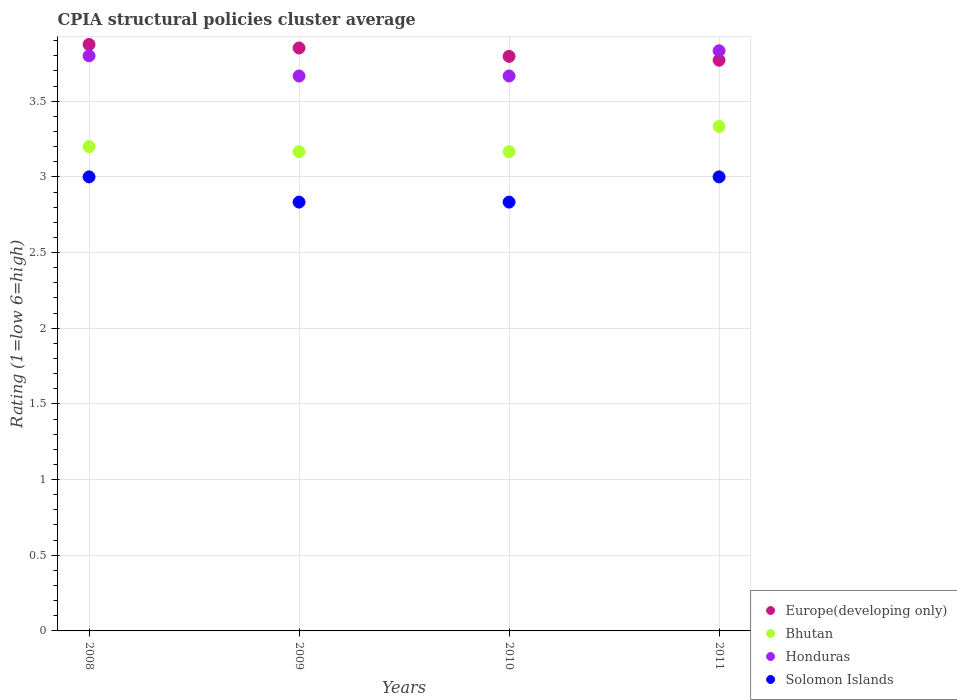How many different coloured dotlines are there?
Provide a succinct answer. 4. What is the CPIA rating in Europe(developing only) in 2010?
Offer a terse response. 3.8. Across all years, what is the maximum CPIA rating in Bhutan?
Provide a succinct answer. 3.33. Across all years, what is the minimum CPIA rating in Europe(developing only)?
Your response must be concise. 3.77. In which year was the CPIA rating in Europe(developing only) minimum?
Provide a short and direct response. 2011. What is the total CPIA rating in Bhutan in the graph?
Provide a short and direct response. 12.87. What is the difference between the CPIA rating in Bhutan in 2008 and that in 2010?
Provide a succinct answer. 0.03. What is the difference between the CPIA rating in Solomon Islands in 2008 and the CPIA rating in Europe(developing only) in 2009?
Make the answer very short. -0.85. What is the average CPIA rating in Solomon Islands per year?
Your answer should be very brief. 2.92. In the year 2011, what is the difference between the CPIA rating in Bhutan and CPIA rating in Honduras?
Offer a very short reply. -0.5. In how many years, is the CPIA rating in Bhutan greater than 3.5?
Your answer should be compact. 0. What is the ratio of the CPIA rating in Solomon Islands in 2008 to that in 2009?
Provide a short and direct response. 1.06. Is the CPIA rating in Europe(developing only) in 2008 less than that in 2009?
Give a very brief answer. No. Is the difference between the CPIA rating in Bhutan in 2008 and 2010 greater than the difference between the CPIA rating in Honduras in 2008 and 2010?
Offer a terse response. No. What is the difference between the highest and the lowest CPIA rating in Solomon Islands?
Offer a very short reply. 0.17. In how many years, is the CPIA rating in Europe(developing only) greater than the average CPIA rating in Europe(developing only) taken over all years?
Offer a terse response. 2. Is the CPIA rating in Europe(developing only) strictly greater than the CPIA rating in Honduras over the years?
Provide a short and direct response. No. Is the CPIA rating in Europe(developing only) strictly less than the CPIA rating in Honduras over the years?
Your answer should be very brief. No. How many dotlines are there?
Give a very brief answer. 4. What is the difference between two consecutive major ticks on the Y-axis?
Your answer should be compact. 0.5. Does the graph contain any zero values?
Your answer should be compact. No. Does the graph contain grids?
Keep it short and to the point. Yes. What is the title of the graph?
Give a very brief answer. CPIA structural policies cluster average. What is the label or title of the X-axis?
Provide a succinct answer. Years. What is the Rating (1=low 6=high) of Europe(developing only) in 2008?
Your response must be concise. 3.88. What is the Rating (1=low 6=high) of Europe(developing only) in 2009?
Your response must be concise. 3.85. What is the Rating (1=low 6=high) of Bhutan in 2009?
Offer a terse response. 3.17. What is the Rating (1=low 6=high) in Honduras in 2009?
Make the answer very short. 3.67. What is the Rating (1=low 6=high) in Solomon Islands in 2009?
Your answer should be very brief. 2.83. What is the Rating (1=low 6=high) of Europe(developing only) in 2010?
Ensure brevity in your answer.  3.8. What is the Rating (1=low 6=high) in Bhutan in 2010?
Give a very brief answer. 3.17. What is the Rating (1=low 6=high) in Honduras in 2010?
Keep it short and to the point. 3.67. What is the Rating (1=low 6=high) in Solomon Islands in 2010?
Your response must be concise. 2.83. What is the Rating (1=low 6=high) of Europe(developing only) in 2011?
Provide a short and direct response. 3.77. What is the Rating (1=low 6=high) in Bhutan in 2011?
Ensure brevity in your answer.  3.33. What is the Rating (1=low 6=high) in Honduras in 2011?
Your answer should be compact. 3.83. Across all years, what is the maximum Rating (1=low 6=high) in Europe(developing only)?
Ensure brevity in your answer.  3.88. Across all years, what is the maximum Rating (1=low 6=high) in Bhutan?
Keep it short and to the point. 3.33. Across all years, what is the maximum Rating (1=low 6=high) in Honduras?
Ensure brevity in your answer.  3.83. Across all years, what is the minimum Rating (1=low 6=high) in Europe(developing only)?
Your answer should be very brief. 3.77. Across all years, what is the minimum Rating (1=low 6=high) of Bhutan?
Give a very brief answer. 3.17. Across all years, what is the minimum Rating (1=low 6=high) in Honduras?
Ensure brevity in your answer.  3.67. Across all years, what is the minimum Rating (1=low 6=high) of Solomon Islands?
Your answer should be compact. 2.83. What is the total Rating (1=low 6=high) of Europe(developing only) in the graph?
Ensure brevity in your answer.  15.29. What is the total Rating (1=low 6=high) in Bhutan in the graph?
Keep it short and to the point. 12.87. What is the total Rating (1=low 6=high) in Honduras in the graph?
Make the answer very short. 14.97. What is the total Rating (1=low 6=high) of Solomon Islands in the graph?
Offer a very short reply. 11.67. What is the difference between the Rating (1=low 6=high) in Europe(developing only) in 2008 and that in 2009?
Offer a terse response. 0.02. What is the difference between the Rating (1=low 6=high) of Bhutan in 2008 and that in 2009?
Make the answer very short. 0.03. What is the difference between the Rating (1=low 6=high) in Honduras in 2008 and that in 2009?
Your answer should be very brief. 0.13. What is the difference between the Rating (1=low 6=high) of Europe(developing only) in 2008 and that in 2010?
Your answer should be compact. 0.08. What is the difference between the Rating (1=low 6=high) of Bhutan in 2008 and that in 2010?
Ensure brevity in your answer.  0.03. What is the difference between the Rating (1=low 6=high) in Honduras in 2008 and that in 2010?
Ensure brevity in your answer.  0.13. What is the difference between the Rating (1=low 6=high) of Solomon Islands in 2008 and that in 2010?
Keep it short and to the point. 0.17. What is the difference between the Rating (1=low 6=high) in Europe(developing only) in 2008 and that in 2011?
Your response must be concise. 0.1. What is the difference between the Rating (1=low 6=high) in Bhutan in 2008 and that in 2011?
Provide a succinct answer. -0.13. What is the difference between the Rating (1=low 6=high) in Honduras in 2008 and that in 2011?
Your response must be concise. -0.03. What is the difference between the Rating (1=low 6=high) in Europe(developing only) in 2009 and that in 2010?
Offer a very short reply. 0.06. What is the difference between the Rating (1=low 6=high) in Bhutan in 2009 and that in 2010?
Your answer should be compact. 0. What is the difference between the Rating (1=low 6=high) of Honduras in 2009 and that in 2010?
Make the answer very short. 0. What is the difference between the Rating (1=low 6=high) of Europe(developing only) in 2009 and that in 2011?
Provide a succinct answer. 0.08. What is the difference between the Rating (1=low 6=high) of Honduras in 2009 and that in 2011?
Your answer should be compact. -0.17. What is the difference between the Rating (1=low 6=high) of Solomon Islands in 2009 and that in 2011?
Your answer should be compact. -0.17. What is the difference between the Rating (1=low 6=high) in Europe(developing only) in 2010 and that in 2011?
Offer a very short reply. 0.03. What is the difference between the Rating (1=low 6=high) of Honduras in 2010 and that in 2011?
Your answer should be compact. -0.17. What is the difference between the Rating (1=low 6=high) of Solomon Islands in 2010 and that in 2011?
Provide a succinct answer. -0.17. What is the difference between the Rating (1=low 6=high) of Europe(developing only) in 2008 and the Rating (1=low 6=high) of Bhutan in 2009?
Give a very brief answer. 0.71. What is the difference between the Rating (1=low 6=high) of Europe(developing only) in 2008 and the Rating (1=low 6=high) of Honduras in 2009?
Provide a succinct answer. 0.21. What is the difference between the Rating (1=low 6=high) in Europe(developing only) in 2008 and the Rating (1=low 6=high) in Solomon Islands in 2009?
Keep it short and to the point. 1.04. What is the difference between the Rating (1=low 6=high) of Bhutan in 2008 and the Rating (1=low 6=high) of Honduras in 2009?
Ensure brevity in your answer.  -0.47. What is the difference between the Rating (1=low 6=high) of Bhutan in 2008 and the Rating (1=low 6=high) of Solomon Islands in 2009?
Your response must be concise. 0.37. What is the difference between the Rating (1=low 6=high) in Honduras in 2008 and the Rating (1=low 6=high) in Solomon Islands in 2009?
Offer a terse response. 0.97. What is the difference between the Rating (1=low 6=high) in Europe(developing only) in 2008 and the Rating (1=low 6=high) in Bhutan in 2010?
Make the answer very short. 0.71. What is the difference between the Rating (1=low 6=high) in Europe(developing only) in 2008 and the Rating (1=low 6=high) in Honduras in 2010?
Provide a succinct answer. 0.21. What is the difference between the Rating (1=low 6=high) of Europe(developing only) in 2008 and the Rating (1=low 6=high) of Solomon Islands in 2010?
Make the answer very short. 1.04. What is the difference between the Rating (1=low 6=high) of Bhutan in 2008 and the Rating (1=low 6=high) of Honduras in 2010?
Provide a short and direct response. -0.47. What is the difference between the Rating (1=low 6=high) in Bhutan in 2008 and the Rating (1=low 6=high) in Solomon Islands in 2010?
Your answer should be compact. 0.37. What is the difference between the Rating (1=low 6=high) of Honduras in 2008 and the Rating (1=low 6=high) of Solomon Islands in 2010?
Offer a terse response. 0.97. What is the difference between the Rating (1=low 6=high) of Europe(developing only) in 2008 and the Rating (1=low 6=high) of Bhutan in 2011?
Your response must be concise. 0.54. What is the difference between the Rating (1=low 6=high) in Europe(developing only) in 2008 and the Rating (1=low 6=high) in Honduras in 2011?
Make the answer very short. 0.04. What is the difference between the Rating (1=low 6=high) of Bhutan in 2008 and the Rating (1=low 6=high) of Honduras in 2011?
Offer a terse response. -0.63. What is the difference between the Rating (1=low 6=high) in Bhutan in 2008 and the Rating (1=low 6=high) in Solomon Islands in 2011?
Ensure brevity in your answer.  0.2. What is the difference between the Rating (1=low 6=high) of Honduras in 2008 and the Rating (1=low 6=high) of Solomon Islands in 2011?
Offer a very short reply. 0.8. What is the difference between the Rating (1=low 6=high) in Europe(developing only) in 2009 and the Rating (1=low 6=high) in Bhutan in 2010?
Your response must be concise. 0.69. What is the difference between the Rating (1=low 6=high) of Europe(developing only) in 2009 and the Rating (1=low 6=high) of Honduras in 2010?
Offer a very short reply. 0.19. What is the difference between the Rating (1=low 6=high) in Europe(developing only) in 2009 and the Rating (1=low 6=high) in Solomon Islands in 2010?
Ensure brevity in your answer.  1.02. What is the difference between the Rating (1=low 6=high) in Bhutan in 2009 and the Rating (1=low 6=high) in Honduras in 2010?
Your response must be concise. -0.5. What is the difference between the Rating (1=low 6=high) of Bhutan in 2009 and the Rating (1=low 6=high) of Solomon Islands in 2010?
Your answer should be very brief. 0.33. What is the difference between the Rating (1=low 6=high) of Honduras in 2009 and the Rating (1=low 6=high) of Solomon Islands in 2010?
Offer a terse response. 0.83. What is the difference between the Rating (1=low 6=high) of Europe(developing only) in 2009 and the Rating (1=low 6=high) of Bhutan in 2011?
Your response must be concise. 0.52. What is the difference between the Rating (1=low 6=high) of Europe(developing only) in 2009 and the Rating (1=low 6=high) of Honduras in 2011?
Make the answer very short. 0.02. What is the difference between the Rating (1=low 6=high) in Europe(developing only) in 2009 and the Rating (1=low 6=high) in Solomon Islands in 2011?
Your answer should be very brief. 0.85. What is the difference between the Rating (1=low 6=high) in Bhutan in 2009 and the Rating (1=low 6=high) in Honduras in 2011?
Offer a terse response. -0.67. What is the difference between the Rating (1=low 6=high) of Bhutan in 2009 and the Rating (1=low 6=high) of Solomon Islands in 2011?
Your answer should be very brief. 0.17. What is the difference between the Rating (1=low 6=high) of Honduras in 2009 and the Rating (1=low 6=high) of Solomon Islands in 2011?
Ensure brevity in your answer.  0.67. What is the difference between the Rating (1=low 6=high) of Europe(developing only) in 2010 and the Rating (1=low 6=high) of Bhutan in 2011?
Your answer should be very brief. 0.46. What is the difference between the Rating (1=low 6=high) in Europe(developing only) in 2010 and the Rating (1=low 6=high) in Honduras in 2011?
Make the answer very short. -0.04. What is the difference between the Rating (1=low 6=high) of Europe(developing only) in 2010 and the Rating (1=low 6=high) of Solomon Islands in 2011?
Ensure brevity in your answer.  0.8. What is the difference between the Rating (1=low 6=high) in Bhutan in 2010 and the Rating (1=low 6=high) in Solomon Islands in 2011?
Keep it short and to the point. 0.17. What is the difference between the Rating (1=low 6=high) in Honduras in 2010 and the Rating (1=low 6=high) in Solomon Islands in 2011?
Ensure brevity in your answer.  0.67. What is the average Rating (1=low 6=high) of Europe(developing only) per year?
Your answer should be very brief. 3.82. What is the average Rating (1=low 6=high) of Bhutan per year?
Give a very brief answer. 3.22. What is the average Rating (1=low 6=high) in Honduras per year?
Give a very brief answer. 3.74. What is the average Rating (1=low 6=high) of Solomon Islands per year?
Your answer should be very brief. 2.92. In the year 2008, what is the difference between the Rating (1=low 6=high) in Europe(developing only) and Rating (1=low 6=high) in Bhutan?
Give a very brief answer. 0.68. In the year 2008, what is the difference between the Rating (1=low 6=high) in Europe(developing only) and Rating (1=low 6=high) in Honduras?
Make the answer very short. 0.07. In the year 2008, what is the difference between the Rating (1=low 6=high) of Bhutan and Rating (1=low 6=high) of Solomon Islands?
Keep it short and to the point. 0.2. In the year 2009, what is the difference between the Rating (1=low 6=high) in Europe(developing only) and Rating (1=low 6=high) in Bhutan?
Offer a very short reply. 0.69. In the year 2009, what is the difference between the Rating (1=low 6=high) in Europe(developing only) and Rating (1=low 6=high) in Honduras?
Your response must be concise. 0.19. In the year 2009, what is the difference between the Rating (1=low 6=high) in Europe(developing only) and Rating (1=low 6=high) in Solomon Islands?
Provide a succinct answer. 1.02. In the year 2009, what is the difference between the Rating (1=low 6=high) of Bhutan and Rating (1=low 6=high) of Honduras?
Your answer should be compact. -0.5. In the year 2010, what is the difference between the Rating (1=low 6=high) in Europe(developing only) and Rating (1=low 6=high) in Bhutan?
Give a very brief answer. 0.63. In the year 2010, what is the difference between the Rating (1=low 6=high) in Europe(developing only) and Rating (1=low 6=high) in Honduras?
Offer a very short reply. 0.13. In the year 2010, what is the difference between the Rating (1=low 6=high) of Honduras and Rating (1=low 6=high) of Solomon Islands?
Offer a terse response. 0.83. In the year 2011, what is the difference between the Rating (1=low 6=high) of Europe(developing only) and Rating (1=low 6=high) of Bhutan?
Your answer should be compact. 0.44. In the year 2011, what is the difference between the Rating (1=low 6=high) in Europe(developing only) and Rating (1=low 6=high) in Honduras?
Offer a very short reply. -0.06. In the year 2011, what is the difference between the Rating (1=low 6=high) in Europe(developing only) and Rating (1=low 6=high) in Solomon Islands?
Ensure brevity in your answer.  0.77. In the year 2011, what is the difference between the Rating (1=low 6=high) in Honduras and Rating (1=low 6=high) in Solomon Islands?
Make the answer very short. 0.83. What is the ratio of the Rating (1=low 6=high) in Bhutan in 2008 to that in 2009?
Give a very brief answer. 1.01. What is the ratio of the Rating (1=low 6=high) in Honduras in 2008 to that in 2009?
Make the answer very short. 1.04. What is the ratio of the Rating (1=low 6=high) in Solomon Islands in 2008 to that in 2009?
Provide a short and direct response. 1.06. What is the ratio of the Rating (1=low 6=high) in Europe(developing only) in 2008 to that in 2010?
Make the answer very short. 1.02. What is the ratio of the Rating (1=low 6=high) in Bhutan in 2008 to that in 2010?
Your answer should be compact. 1.01. What is the ratio of the Rating (1=low 6=high) of Honduras in 2008 to that in 2010?
Provide a succinct answer. 1.04. What is the ratio of the Rating (1=low 6=high) in Solomon Islands in 2008 to that in 2010?
Provide a short and direct response. 1.06. What is the ratio of the Rating (1=low 6=high) of Europe(developing only) in 2008 to that in 2011?
Provide a short and direct response. 1.03. What is the ratio of the Rating (1=low 6=high) of Bhutan in 2008 to that in 2011?
Your answer should be compact. 0.96. What is the ratio of the Rating (1=low 6=high) in Europe(developing only) in 2009 to that in 2010?
Provide a short and direct response. 1.01. What is the ratio of the Rating (1=low 6=high) in Honduras in 2009 to that in 2010?
Your response must be concise. 1. What is the ratio of the Rating (1=low 6=high) of Solomon Islands in 2009 to that in 2010?
Ensure brevity in your answer.  1. What is the ratio of the Rating (1=low 6=high) of Europe(developing only) in 2009 to that in 2011?
Give a very brief answer. 1.02. What is the ratio of the Rating (1=low 6=high) in Honduras in 2009 to that in 2011?
Make the answer very short. 0.96. What is the ratio of the Rating (1=low 6=high) of Europe(developing only) in 2010 to that in 2011?
Your response must be concise. 1.01. What is the ratio of the Rating (1=low 6=high) of Bhutan in 2010 to that in 2011?
Give a very brief answer. 0.95. What is the ratio of the Rating (1=low 6=high) in Honduras in 2010 to that in 2011?
Make the answer very short. 0.96. What is the difference between the highest and the second highest Rating (1=low 6=high) of Europe(developing only)?
Provide a succinct answer. 0.02. What is the difference between the highest and the second highest Rating (1=low 6=high) in Bhutan?
Your response must be concise. 0.13. What is the difference between the highest and the second highest Rating (1=low 6=high) of Solomon Islands?
Provide a short and direct response. 0. What is the difference between the highest and the lowest Rating (1=low 6=high) in Europe(developing only)?
Give a very brief answer. 0.1. What is the difference between the highest and the lowest Rating (1=low 6=high) of Bhutan?
Keep it short and to the point. 0.17. What is the difference between the highest and the lowest Rating (1=low 6=high) in Honduras?
Make the answer very short. 0.17. 